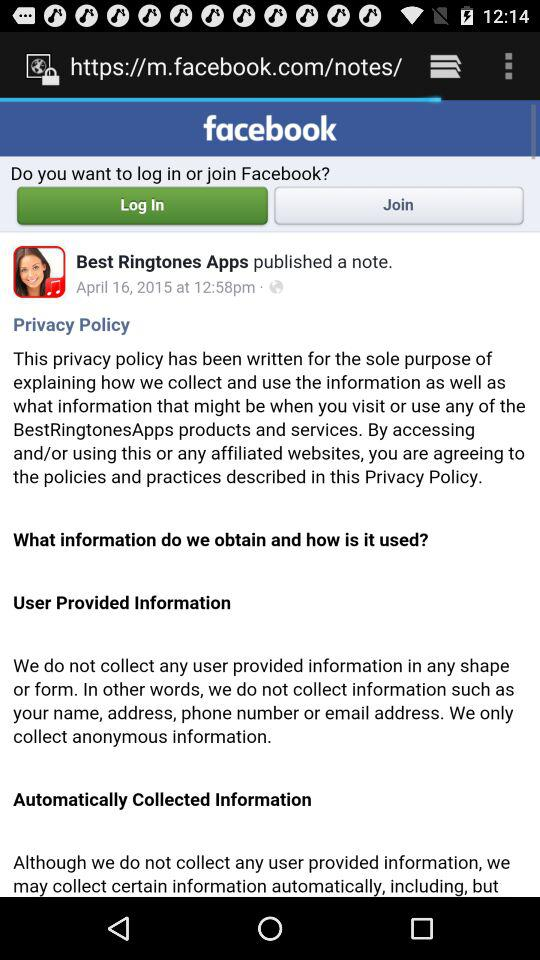Through what application can the user log in? The user can log in through the "Facebook" application. 